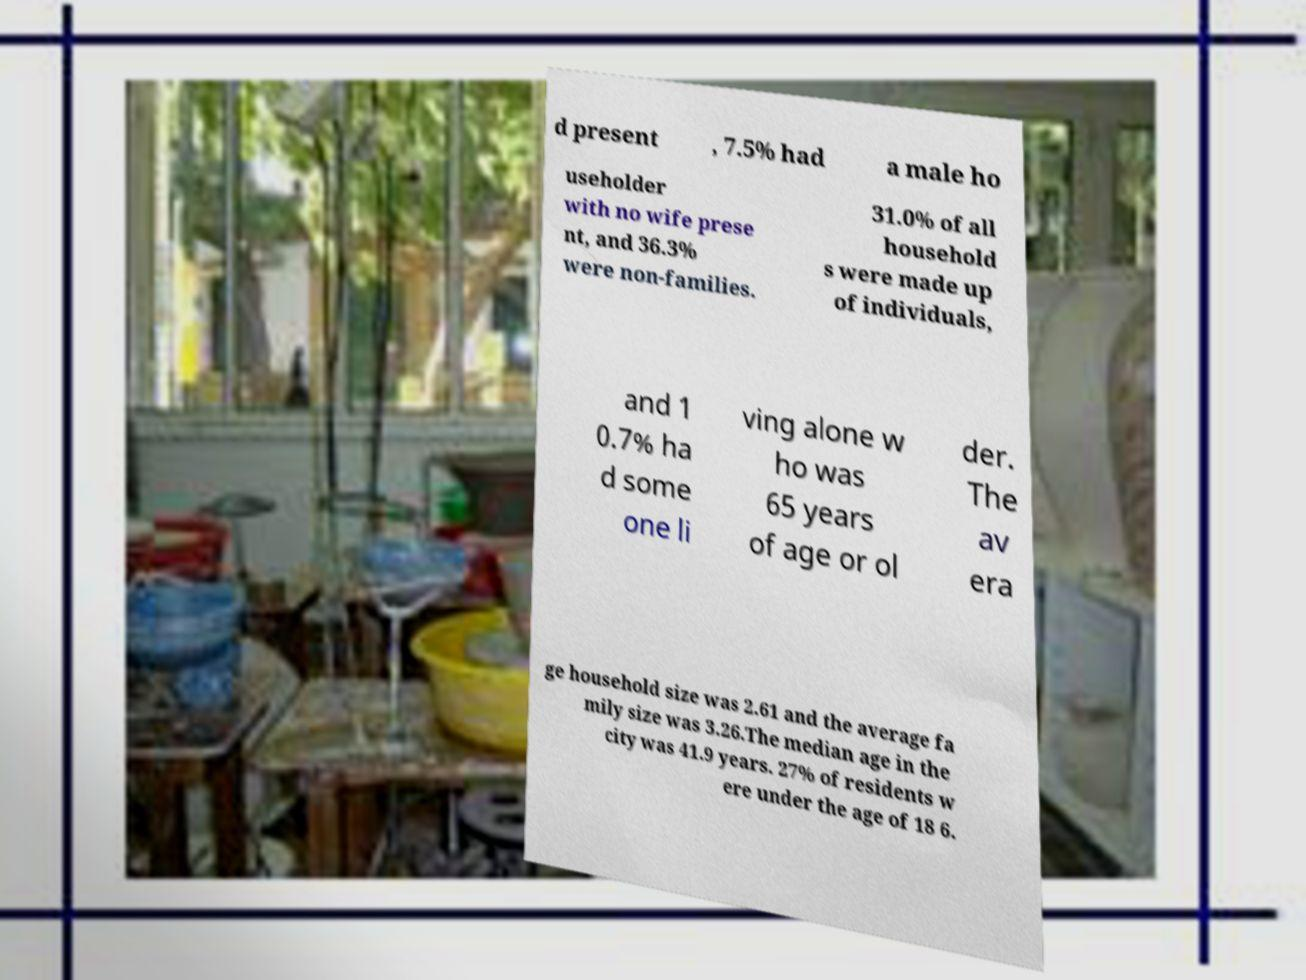There's text embedded in this image that I need extracted. Can you transcribe it verbatim? d present , 7.5% had a male ho useholder with no wife prese nt, and 36.3% were non-families. 31.0% of all household s were made up of individuals, and 1 0.7% ha d some one li ving alone w ho was 65 years of age or ol der. The av era ge household size was 2.61 and the average fa mily size was 3.26.The median age in the city was 41.9 years. 27% of residents w ere under the age of 18 6. 